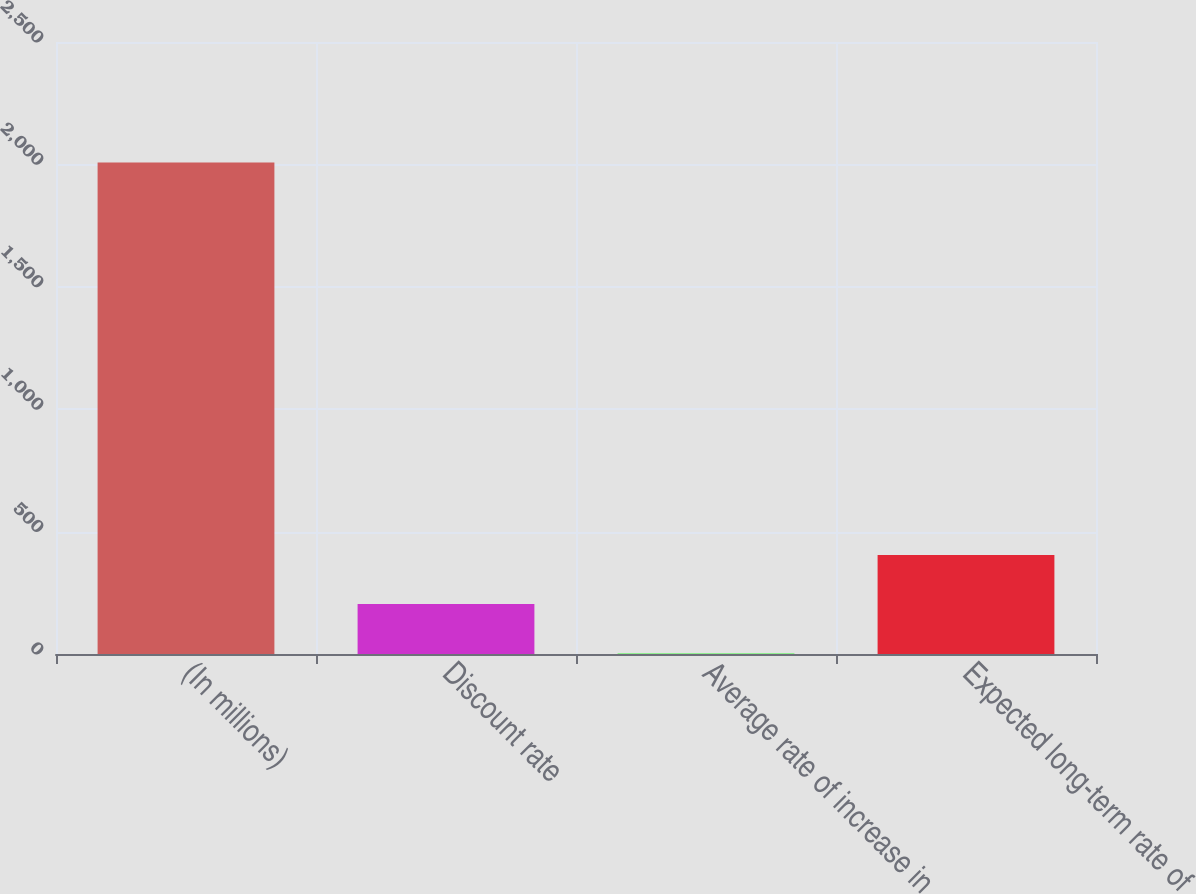Convert chart to OTSL. <chart><loc_0><loc_0><loc_500><loc_500><bar_chart><fcel>(In millions)<fcel>Discount rate<fcel>Average rate of increase in<fcel>Expected long-term rate of<nl><fcel>2008<fcel>204.04<fcel>3.6<fcel>404.48<nl></chart> 